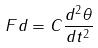Convert formula to latex. <formula><loc_0><loc_0><loc_500><loc_500>F d = C \frac { d ^ { 2 } \theta } { d t ^ { 2 } }</formula> 